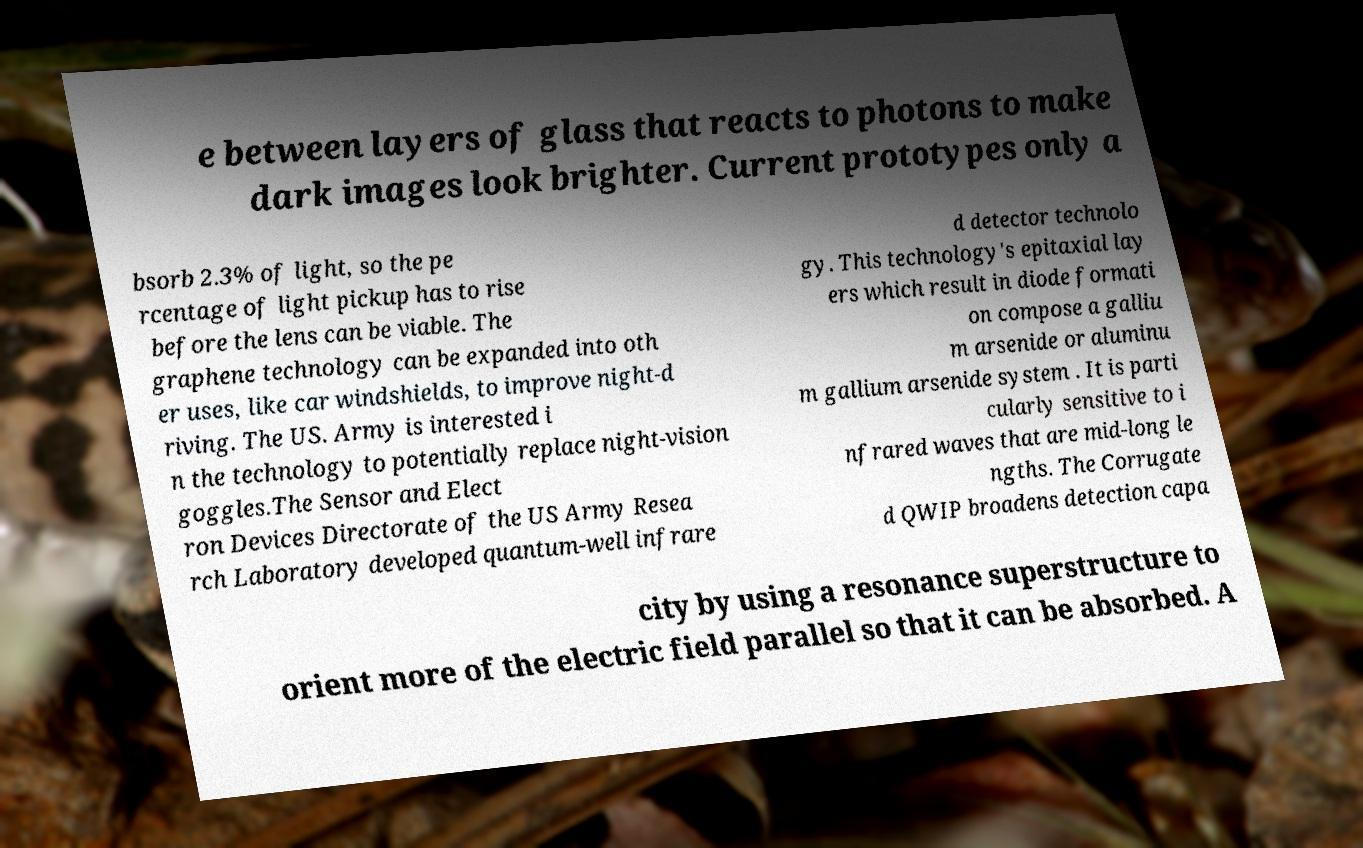Can you read and provide the text displayed in the image?This photo seems to have some interesting text. Can you extract and type it out for me? e between layers of glass that reacts to photons to make dark images look brighter. Current prototypes only a bsorb 2.3% of light, so the pe rcentage of light pickup has to rise before the lens can be viable. The graphene technology can be expanded into oth er uses, like car windshields, to improve night-d riving. The US. Army is interested i n the technology to potentially replace night-vision goggles.The Sensor and Elect ron Devices Directorate of the US Army Resea rch Laboratory developed quantum-well infrare d detector technolo gy. This technology's epitaxial lay ers which result in diode formati on compose a galliu m arsenide or aluminu m gallium arsenide system . It is parti cularly sensitive to i nfrared waves that are mid-long le ngths. The Corrugate d QWIP broadens detection capa city by using a resonance superstructure to orient more of the electric field parallel so that it can be absorbed. A 